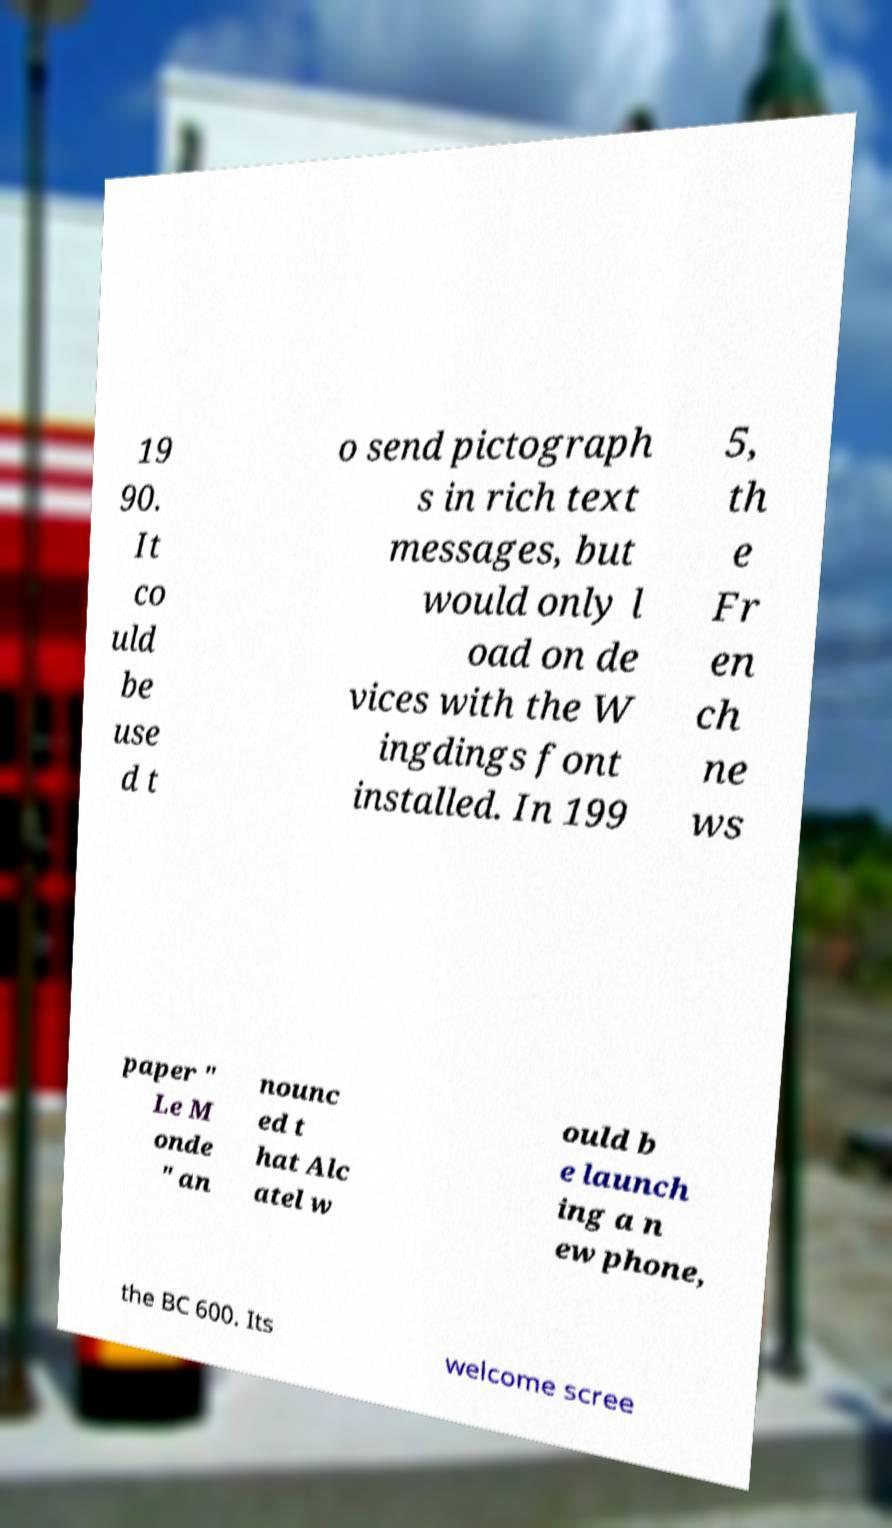There's text embedded in this image that I need extracted. Can you transcribe it verbatim? 19 90. It co uld be use d t o send pictograph s in rich text messages, but would only l oad on de vices with the W ingdings font installed. In 199 5, th e Fr en ch ne ws paper " Le M onde " an nounc ed t hat Alc atel w ould b e launch ing a n ew phone, the BC 600. Its welcome scree 